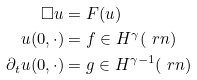<formula> <loc_0><loc_0><loc_500><loc_500>\Box u & = F ( u ) \\ u ( 0 , \cdot ) & = f \in H ^ { \gamma } ( \ r n ) \\ \partial _ { t } u ( 0 , \cdot ) & = g \in H ^ { \gamma - 1 } ( \ r n )</formula> 